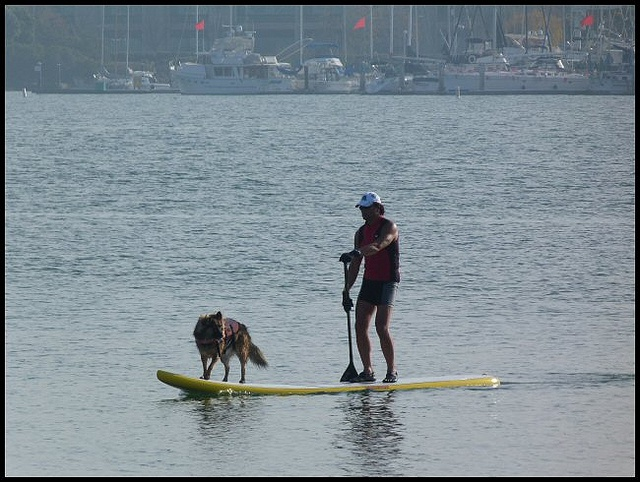Describe the objects in this image and their specific colors. I can see people in black, darkgray, and gray tones, boat in black and gray tones, boat in black, gray, and darkgray tones, surfboard in black, olive, and darkgray tones, and dog in black, gray, and darkgray tones in this image. 